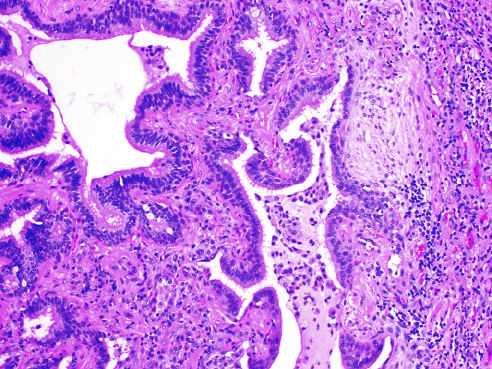s honey-combing present to the left?
Answer the question using a single word or phrase. Yes 